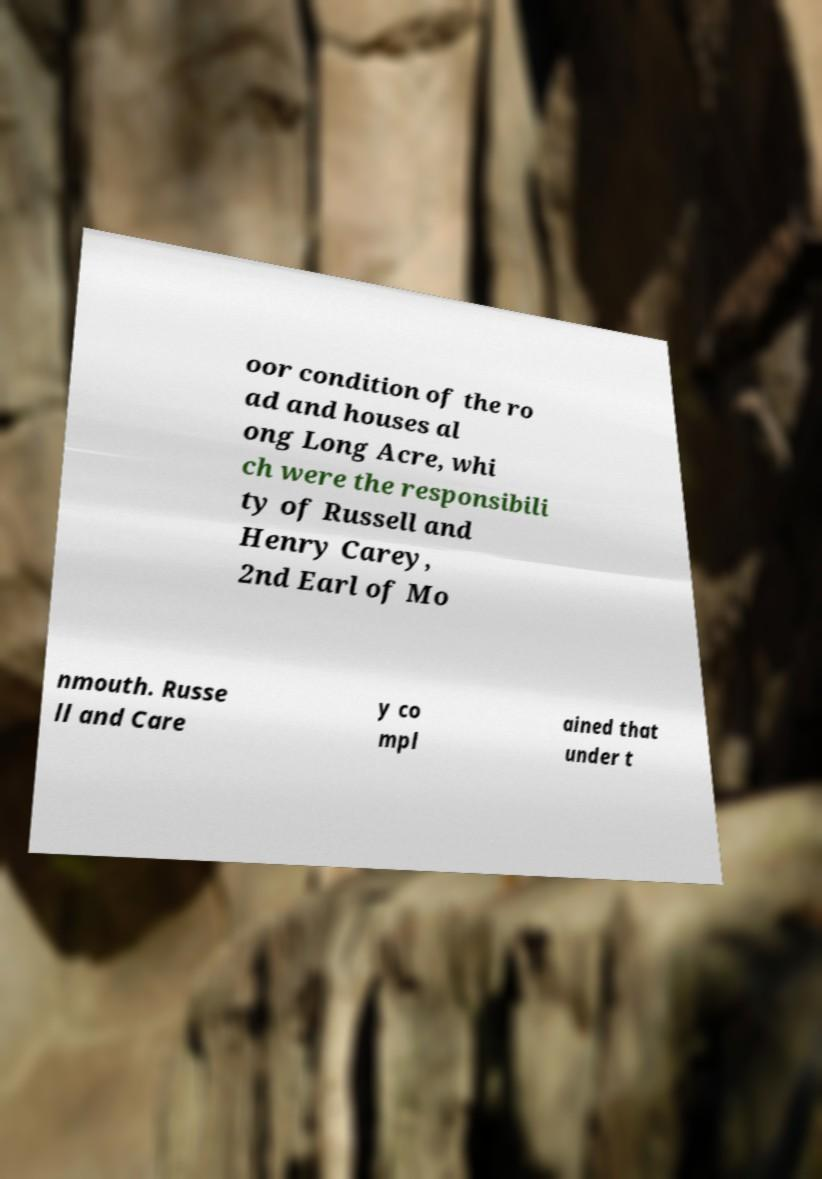Could you assist in decoding the text presented in this image and type it out clearly? oor condition of the ro ad and houses al ong Long Acre, whi ch were the responsibili ty of Russell and Henry Carey, 2nd Earl of Mo nmouth. Russe ll and Care y co mpl ained that under t 